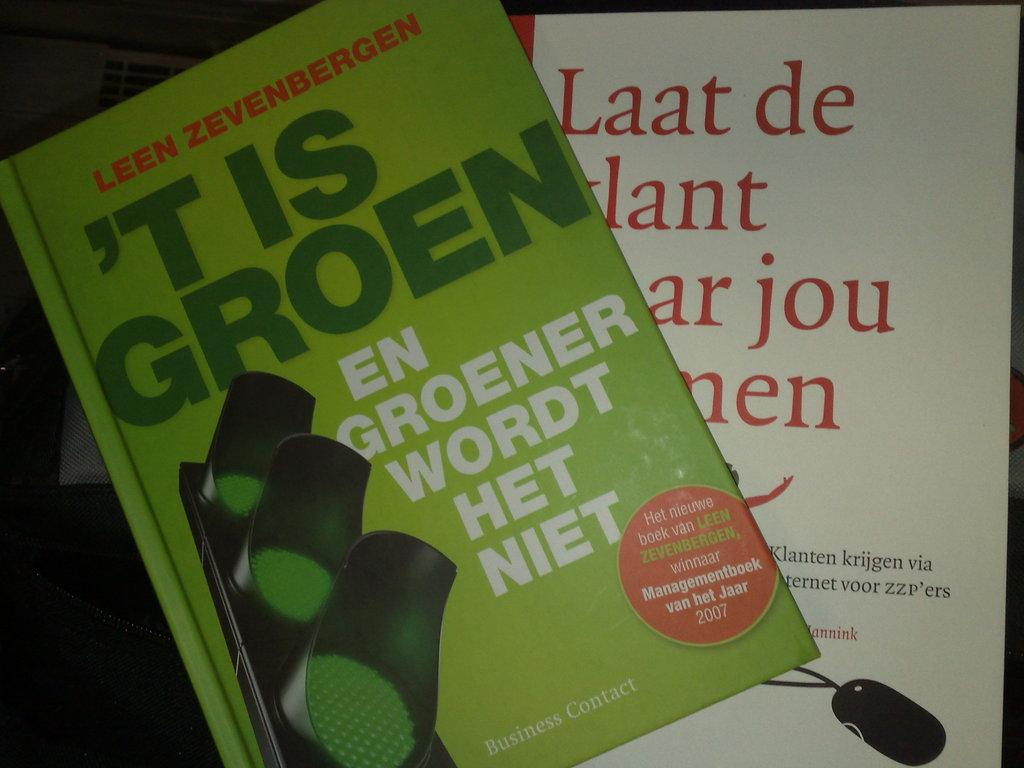<image>
Give a short and clear explanation of the subsequent image. Green book titled "t Is Groen" in front of another book. 